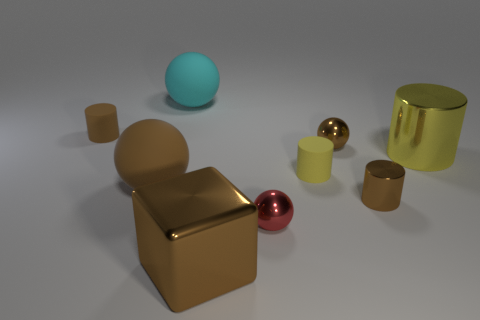What material is the tiny ball that is the same color as the tiny metallic cylinder?
Give a very brief answer. Metal. What number of other things have the same shape as the yellow shiny thing?
Your answer should be compact. 3. Does the brown cube have the same material as the tiny ball in front of the big yellow metal cylinder?
Keep it short and to the point. Yes. There is a brown ball that is the same size as the cyan sphere; what is its material?
Ensure brevity in your answer.  Rubber. Is there a metal cylinder of the same size as the brown metal sphere?
Offer a terse response. Yes. What shape is the brown rubber object that is the same size as the cyan thing?
Offer a very short reply. Sphere. How many other things are the same color as the big metal block?
Offer a very short reply. 4. What shape is the thing that is behind the tiny yellow matte cylinder and on the left side of the big cyan thing?
Ensure brevity in your answer.  Cylinder. Is there a brown rubber cylinder in front of the yellow cylinder that is to the right of the brown sphere right of the big brown block?
Make the answer very short. No. How many other things are there of the same material as the large brown block?
Provide a short and direct response. 4. 